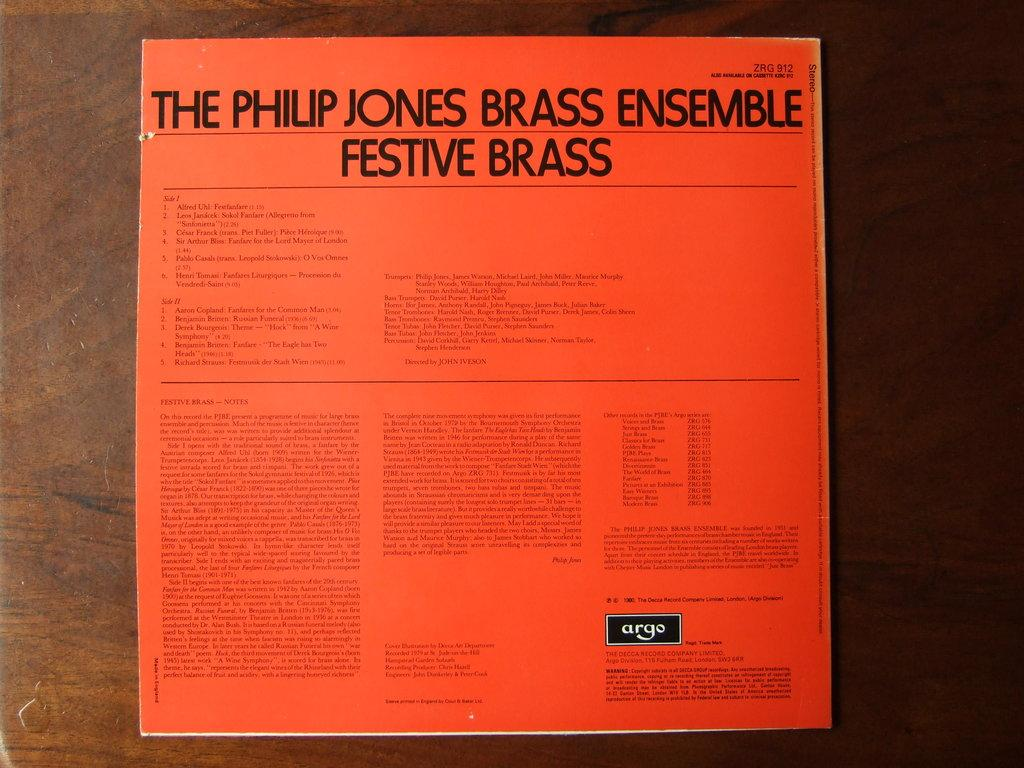Provide a one-sentence caption for the provided image. Orange album cover that says "The Philip Jones Brass Ensemble Festive Brass". 